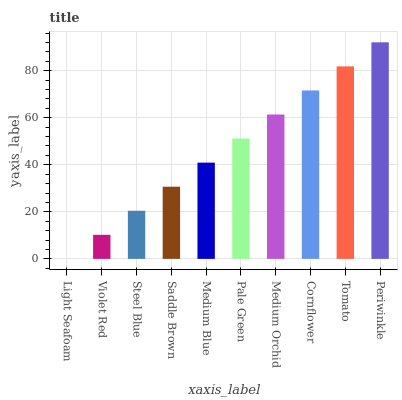Is Light Seafoam the minimum?
Answer yes or no. Yes. Is Periwinkle the maximum?
Answer yes or no. Yes. Is Violet Red the minimum?
Answer yes or no. No. Is Violet Red the maximum?
Answer yes or no. No. Is Violet Red greater than Light Seafoam?
Answer yes or no. Yes. Is Light Seafoam less than Violet Red?
Answer yes or no. Yes. Is Light Seafoam greater than Violet Red?
Answer yes or no. No. Is Violet Red less than Light Seafoam?
Answer yes or no. No. Is Pale Green the high median?
Answer yes or no. Yes. Is Medium Blue the low median?
Answer yes or no. Yes. Is Violet Red the high median?
Answer yes or no. No. Is Saddle Brown the low median?
Answer yes or no. No. 